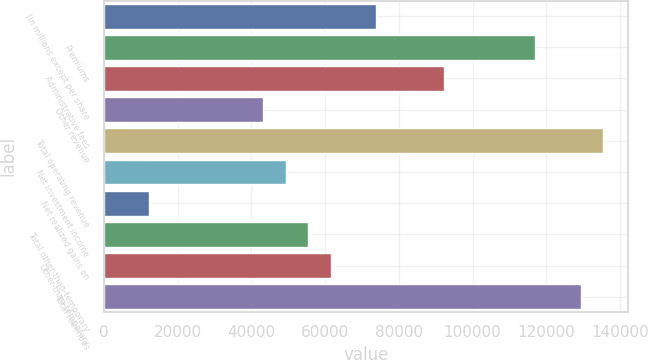Convert chart. <chart><loc_0><loc_0><loc_500><loc_500><bar_chart><fcel>(In millions except per share<fcel>Premiums<fcel>Administrative fees<fcel>Other revenue<fcel>Total operating revenue<fcel>Net investment income<fcel>Net realized gains on<fcel>Total other-than-temporary<fcel>Other-than-temporary<fcel>Total revenues<nl><fcel>73894<fcel>116996<fcel>92366.4<fcel>43106.8<fcel>135468<fcel>49264.3<fcel>12319.6<fcel>55421.7<fcel>61579.2<fcel>129311<nl></chart> 